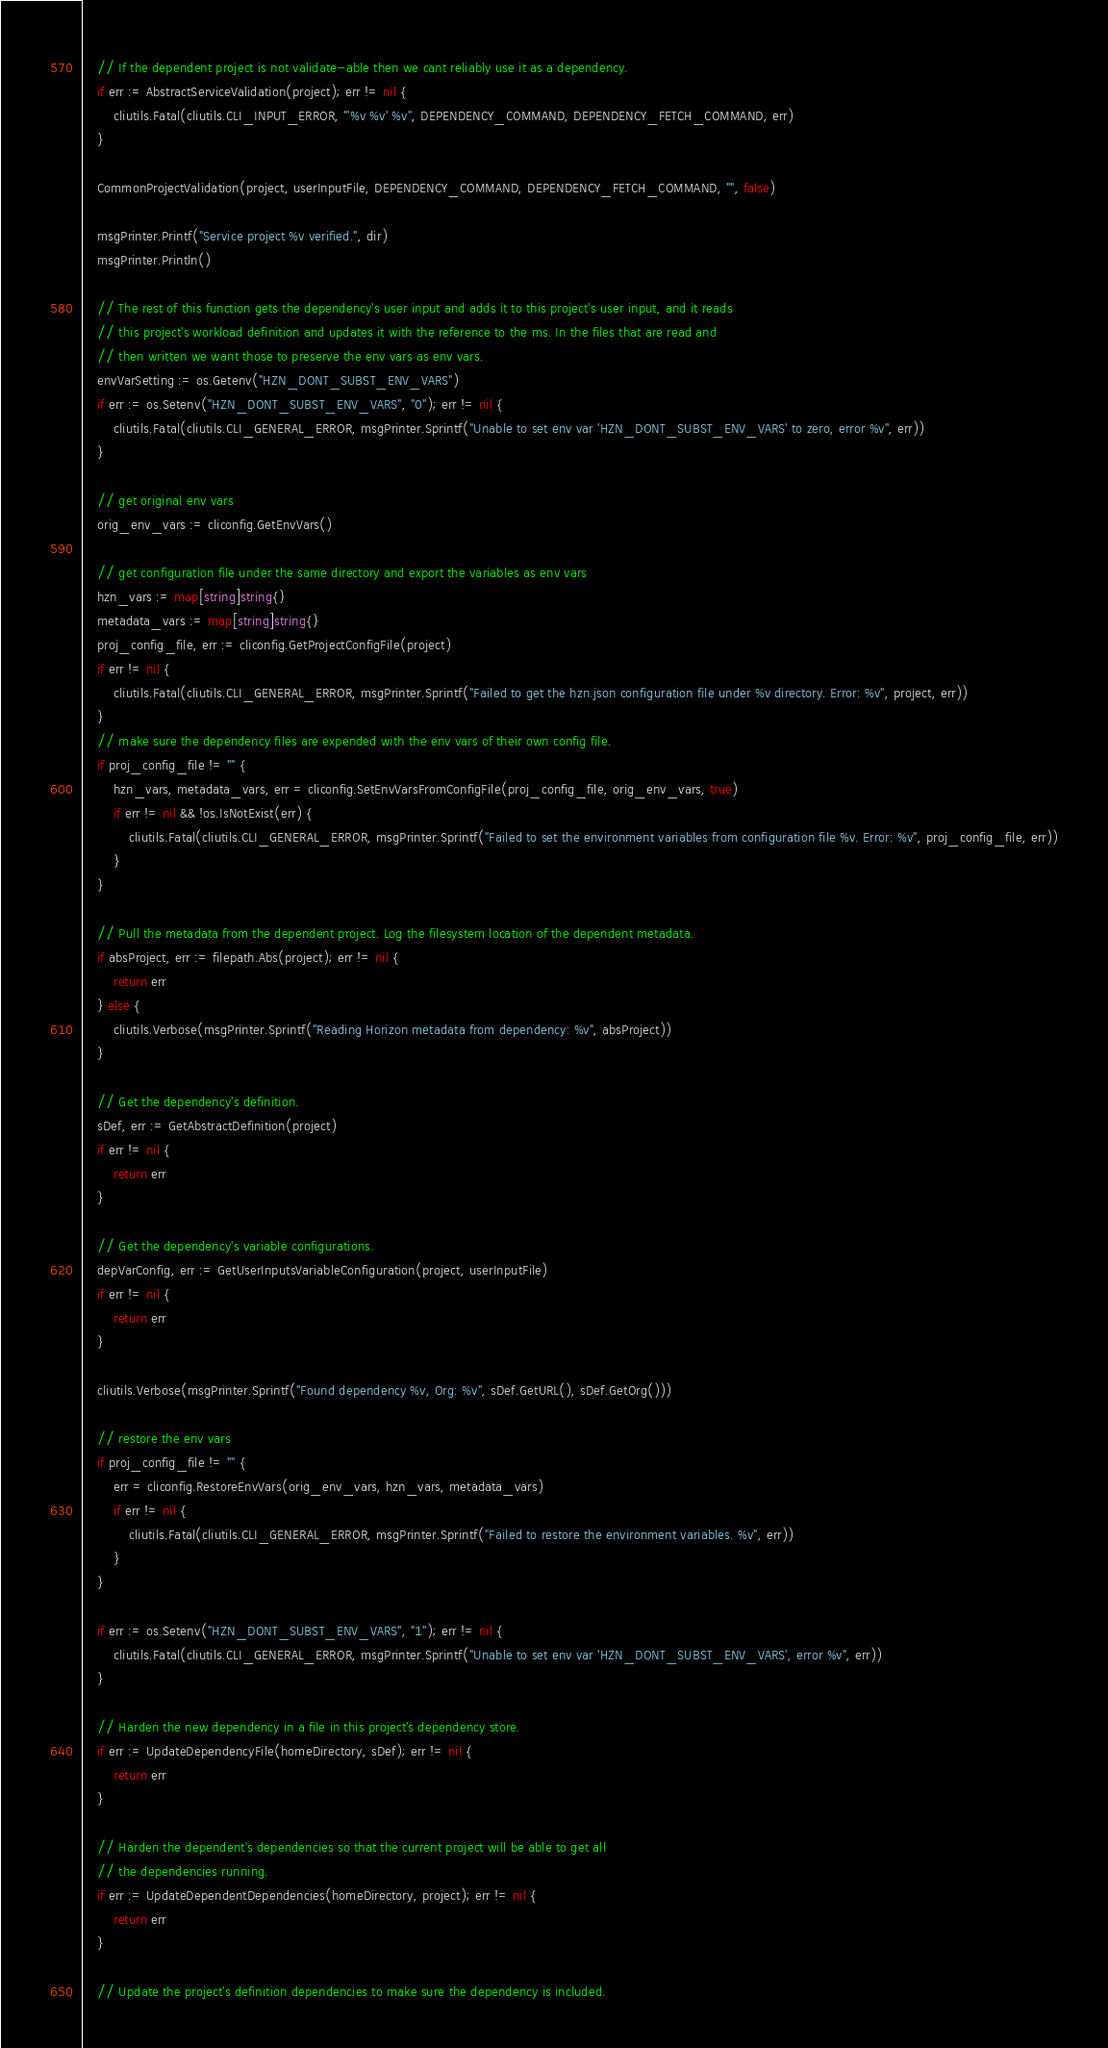Convert code to text. <code><loc_0><loc_0><loc_500><loc_500><_Go_>
	// If the dependent project is not validate-able then we cant reliably use it as a dependency.
	if err := AbstractServiceValidation(project); err != nil {
		cliutils.Fatal(cliutils.CLI_INPUT_ERROR, "'%v %v' %v", DEPENDENCY_COMMAND, DEPENDENCY_FETCH_COMMAND, err)
	}

	CommonProjectValidation(project, userInputFile, DEPENDENCY_COMMAND, DEPENDENCY_FETCH_COMMAND, "", false)

	msgPrinter.Printf("Service project %v verified.", dir)
	msgPrinter.Println()

	// The rest of this function gets the dependency's user input and adds it to this project's user input, and it reads
	// this project's workload definition and updates it with the reference to the ms. In the files that are read and
	// then written we want those to preserve the env vars as env vars.
	envVarSetting := os.Getenv("HZN_DONT_SUBST_ENV_VARS")
	if err := os.Setenv("HZN_DONT_SUBST_ENV_VARS", "0"); err != nil {
		cliutils.Fatal(cliutils.CLI_GENERAL_ERROR, msgPrinter.Sprintf("Unable to set env var 'HZN_DONT_SUBST_ENV_VARS' to zero, error %v", err))
	}

	// get original env vars
	orig_env_vars := cliconfig.GetEnvVars()

	// get configuration file under the same directory and export the variables as env vars
	hzn_vars := map[string]string{}
	metadata_vars := map[string]string{}
	proj_config_file, err := cliconfig.GetProjectConfigFile(project)
	if err != nil {
		cliutils.Fatal(cliutils.CLI_GENERAL_ERROR, msgPrinter.Sprintf("Failed to get the hzn.json configuration file under %v directory. Error: %v", project, err))
	}
	// make sure the dependency files are expended with the env vars of their own config file.
	if proj_config_file != "" {
		hzn_vars, metadata_vars, err = cliconfig.SetEnvVarsFromConfigFile(proj_config_file, orig_env_vars, true)
		if err != nil && !os.IsNotExist(err) {
			cliutils.Fatal(cliutils.CLI_GENERAL_ERROR, msgPrinter.Sprintf("Failed to set the environment variables from configuration file %v. Error: %v", proj_config_file, err))
		}
	}

	// Pull the metadata from the dependent project. Log the filesystem location of the dependent metadata.
	if absProject, err := filepath.Abs(project); err != nil {
		return err
	} else {
		cliutils.Verbose(msgPrinter.Sprintf("Reading Horizon metadata from dependency: %v", absProject))
	}

	// Get the dependency's definition.
	sDef, err := GetAbstractDefinition(project)
	if err != nil {
		return err
	}

	// Get the dependency's variable configurations.
	depVarConfig, err := GetUserInputsVariableConfiguration(project, userInputFile)
	if err != nil {
		return err
	}

	cliutils.Verbose(msgPrinter.Sprintf("Found dependency %v, Org: %v", sDef.GetURL(), sDef.GetOrg()))

	// restore the env vars
	if proj_config_file != "" {
		err = cliconfig.RestoreEnvVars(orig_env_vars, hzn_vars, metadata_vars)
		if err != nil {
			cliutils.Fatal(cliutils.CLI_GENERAL_ERROR, msgPrinter.Sprintf("Failed to restore the environment variables. %v", err))
		}
	}

	if err := os.Setenv("HZN_DONT_SUBST_ENV_VARS", "1"); err != nil {
		cliutils.Fatal(cliutils.CLI_GENERAL_ERROR, msgPrinter.Sprintf("Unable to set env var 'HZN_DONT_SUBST_ENV_VARS', error %v", err))
	}

	// Harden the new dependency in a file in this project's dependency store.
	if err := UpdateDependencyFile(homeDirectory, sDef); err != nil {
		return err
	}

	// Harden the dependent's dependencies so that the current project will be able to get all
	// the dependencies running.
	if err := UpdateDependentDependencies(homeDirectory, project); err != nil {
		return err
	}

	// Update the project's definition dependencies to make sure the dependency is included.</code> 